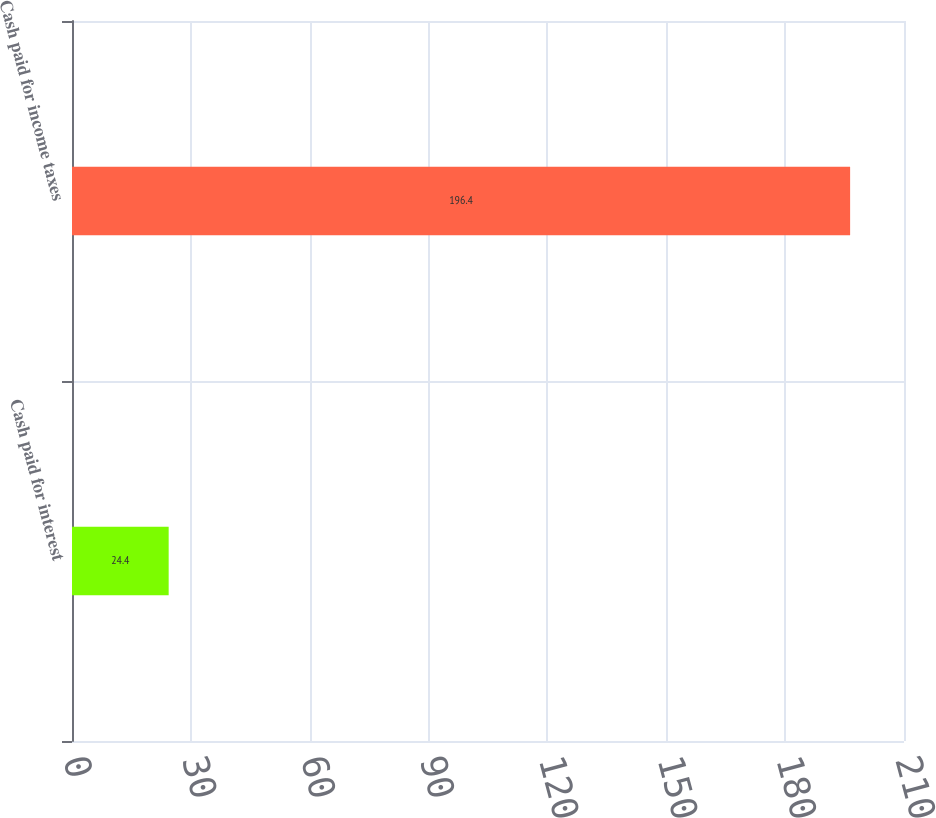Convert chart to OTSL. <chart><loc_0><loc_0><loc_500><loc_500><bar_chart><fcel>Cash paid for interest<fcel>Cash paid for income taxes<nl><fcel>24.4<fcel>196.4<nl></chart> 